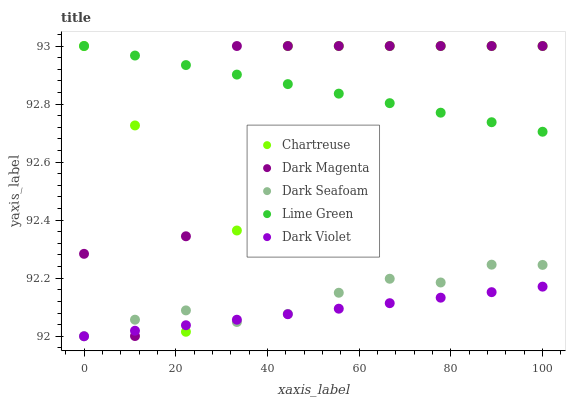Does Dark Violet have the minimum area under the curve?
Answer yes or no. Yes. Does Lime Green have the maximum area under the curve?
Answer yes or no. Yes. Does Chartreuse have the minimum area under the curve?
Answer yes or no. No. Does Chartreuse have the maximum area under the curve?
Answer yes or no. No. Is Lime Green the smoothest?
Answer yes or no. Yes. Is Chartreuse the roughest?
Answer yes or no. Yes. Is Chartreuse the smoothest?
Answer yes or no. No. Is Lime Green the roughest?
Answer yes or no. No. Does Dark Violet have the lowest value?
Answer yes or no. Yes. Does Chartreuse have the lowest value?
Answer yes or no. No. Does Dark Magenta have the highest value?
Answer yes or no. Yes. Does Dark Seafoam have the highest value?
Answer yes or no. No. Is Dark Violet less than Lime Green?
Answer yes or no. Yes. Is Lime Green greater than Dark Seafoam?
Answer yes or no. Yes. Does Dark Seafoam intersect Dark Magenta?
Answer yes or no. Yes. Is Dark Seafoam less than Dark Magenta?
Answer yes or no. No. Is Dark Seafoam greater than Dark Magenta?
Answer yes or no. No. Does Dark Violet intersect Lime Green?
Answer yes or no. No. 